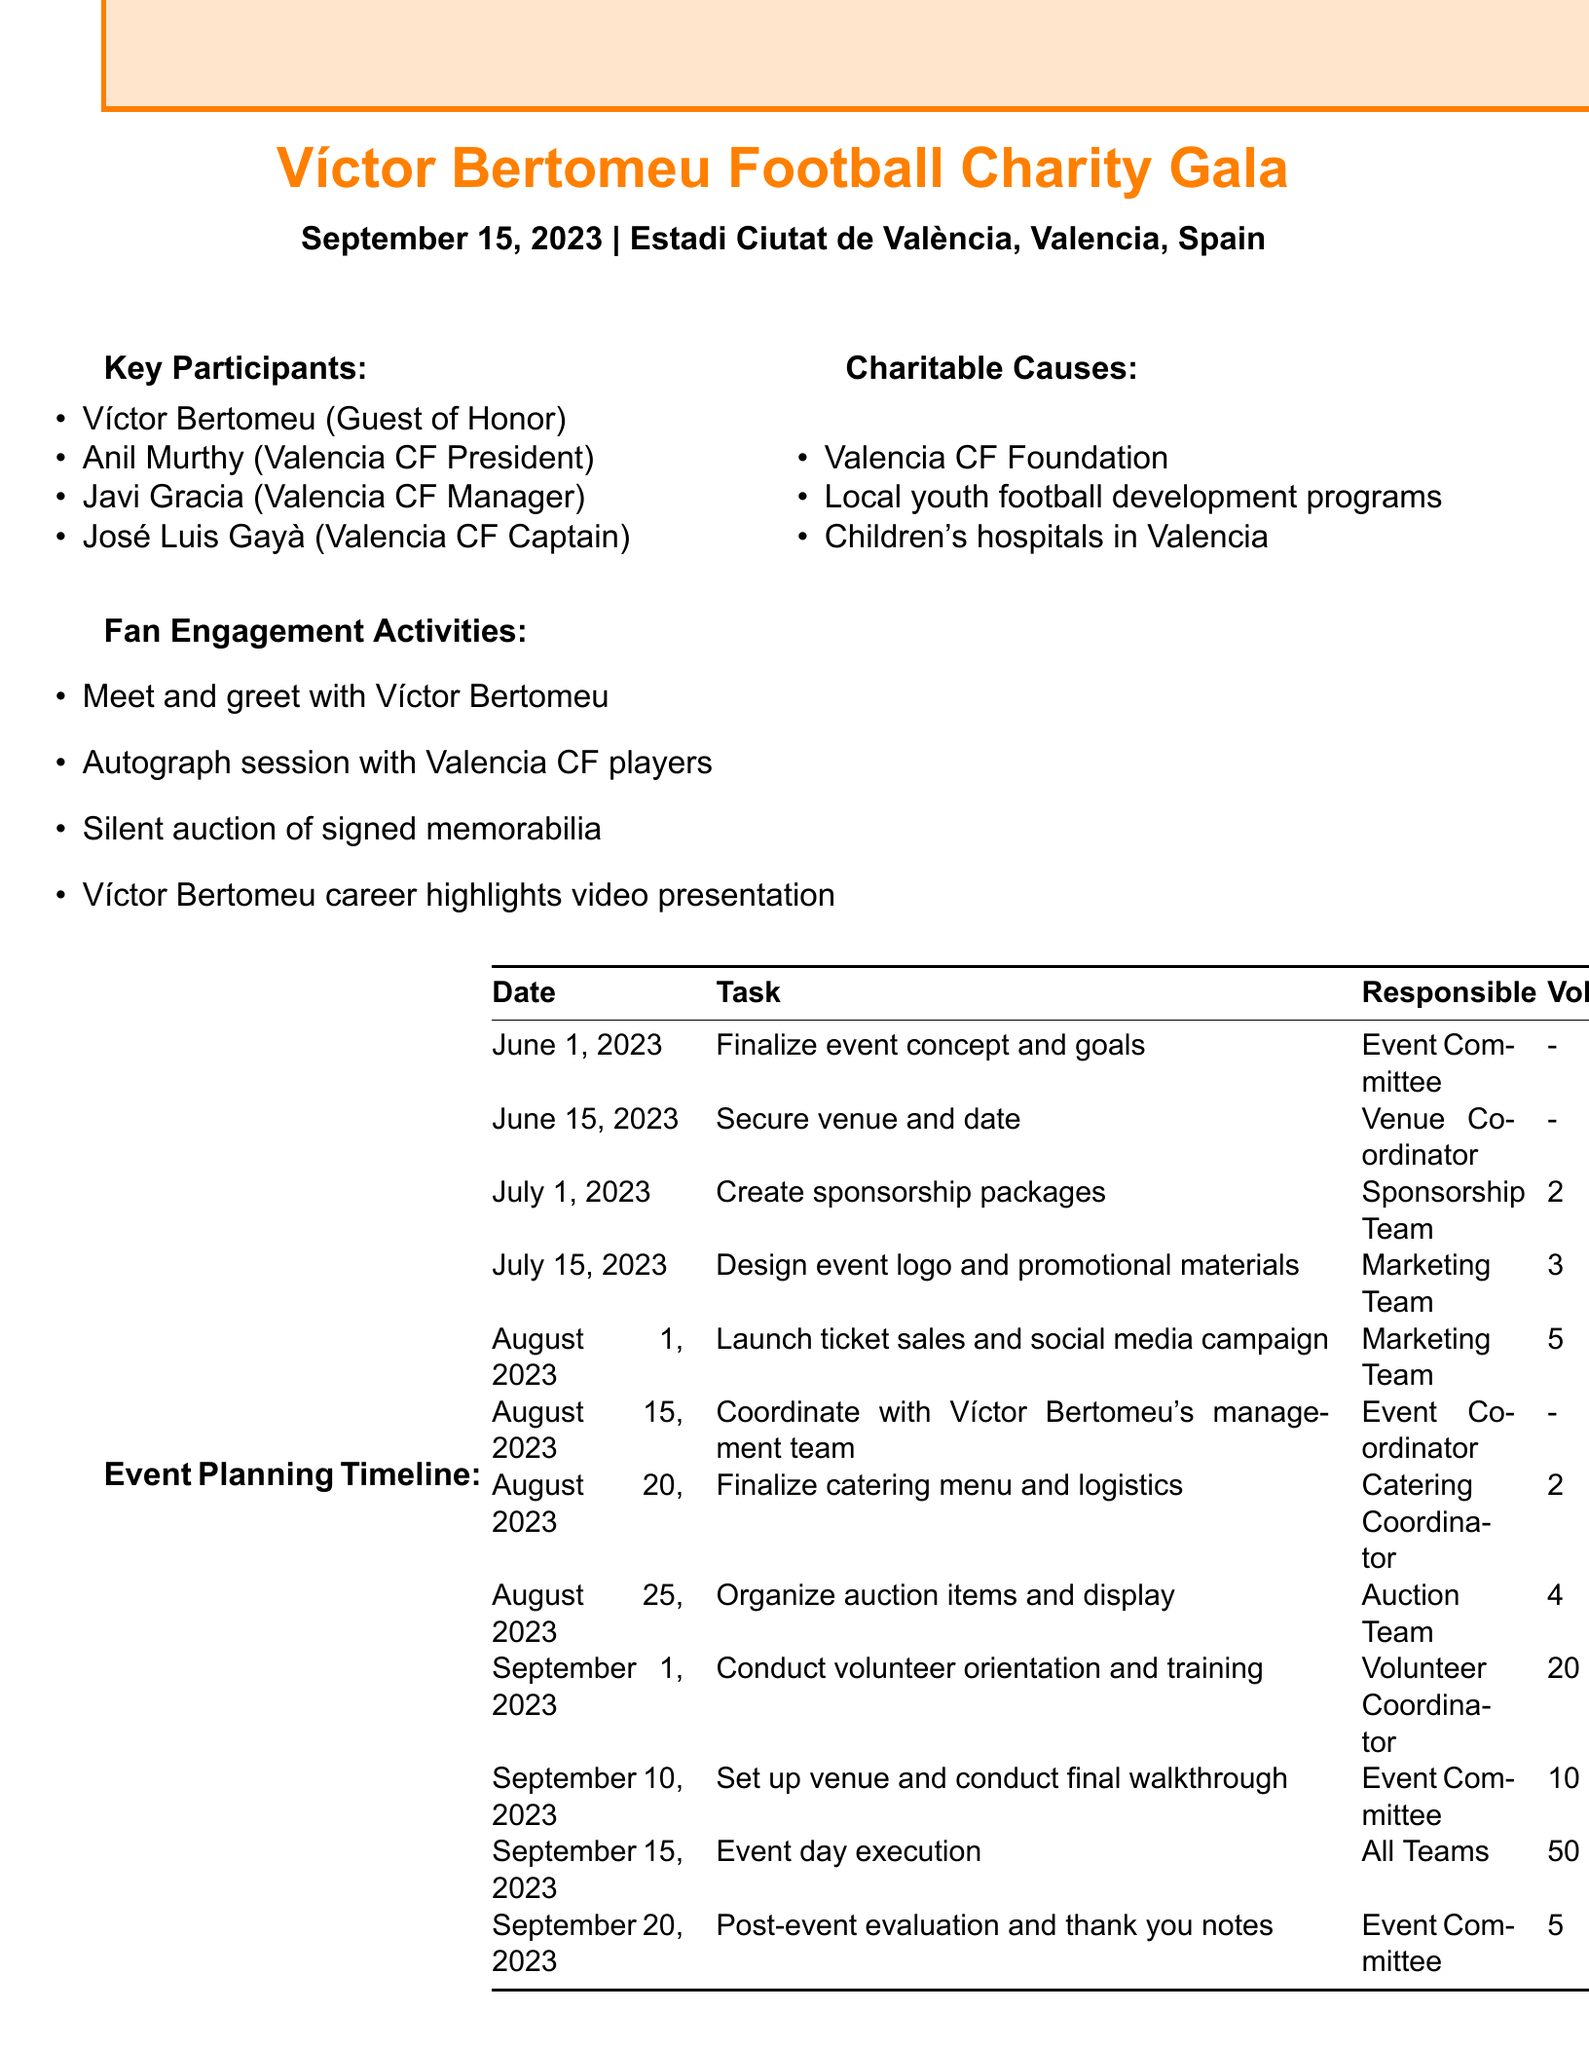What is the event name? The event name is explicitly mentioned in the document.
Answer: Víctor Bertomeu Football Charity Gala When is the event date? The event date is clearly stated.
Answer: September 15, 2023 How many volunteer slots are available for the event day execution? The number of volunteer slots for event day execution can be found in the timeline.
Answer: 50 Who is the Guest of Honor? The Guest of Honor is identified among the key participants.
Answer: Víctor Bertomeu What task is scheduled for August 1, 2023? The task for this date can be found in the planning timeline.
Answer: Launch ticket sales and social media campaign How many volunteers are needed for the volunteer orientation and training on September 1, 2023? The number of volunteers required for this task is listed in the timeline.
Answer: 20 Which team is responsible for creating sponsorship packages? The responsible team for this task is provided in the timeline.
Answer: Sponsorship Team What charitable cause is mentioned alongside the Valencia CF Foundation? The causes listed in the document indicate multiple entries.
Answer: Local youth football development programs What is one of the fan engagement activities? The fan engagement activities are listed, allowing for multiple potential answers.
Answer: Meet and greet with Víctor Bertomeu 